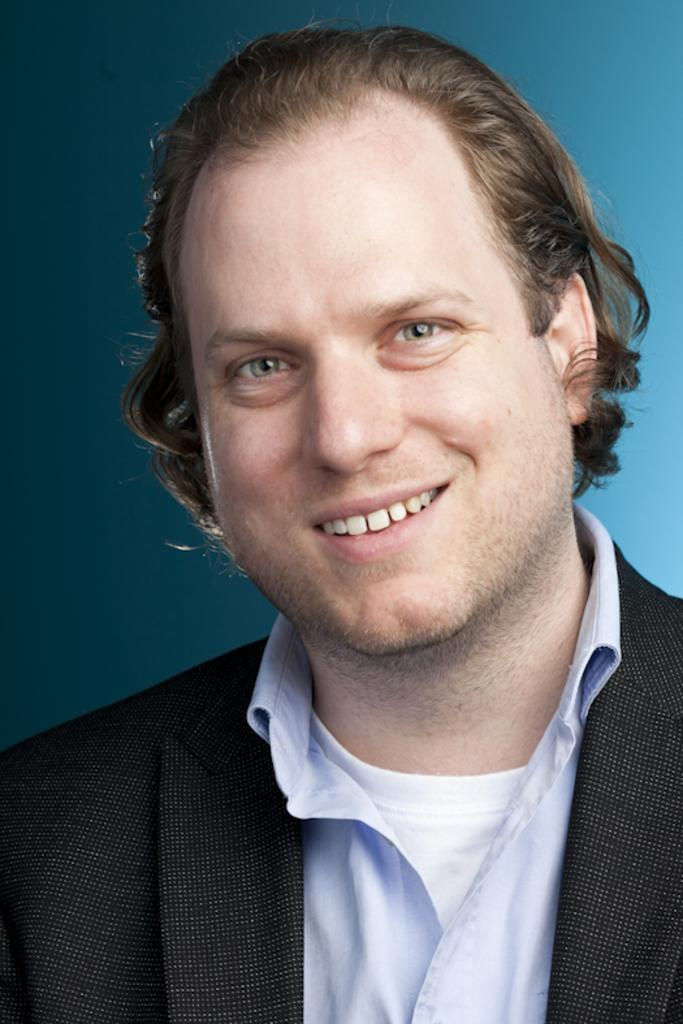Who is the main subject in the image? There is a person in the center of the image. What is the person doing in the image? The person is smiling. What is the person wearing in the image? The person is wearing a different costume. What color is the background of the image? The background of the image is blue. Can you see any fangs on the person in the image? There are no fangs visible on the person in the image. What type of drum is being played by the person in the image? There is no drum present in the image; the person is wearing a costume and smiling. 